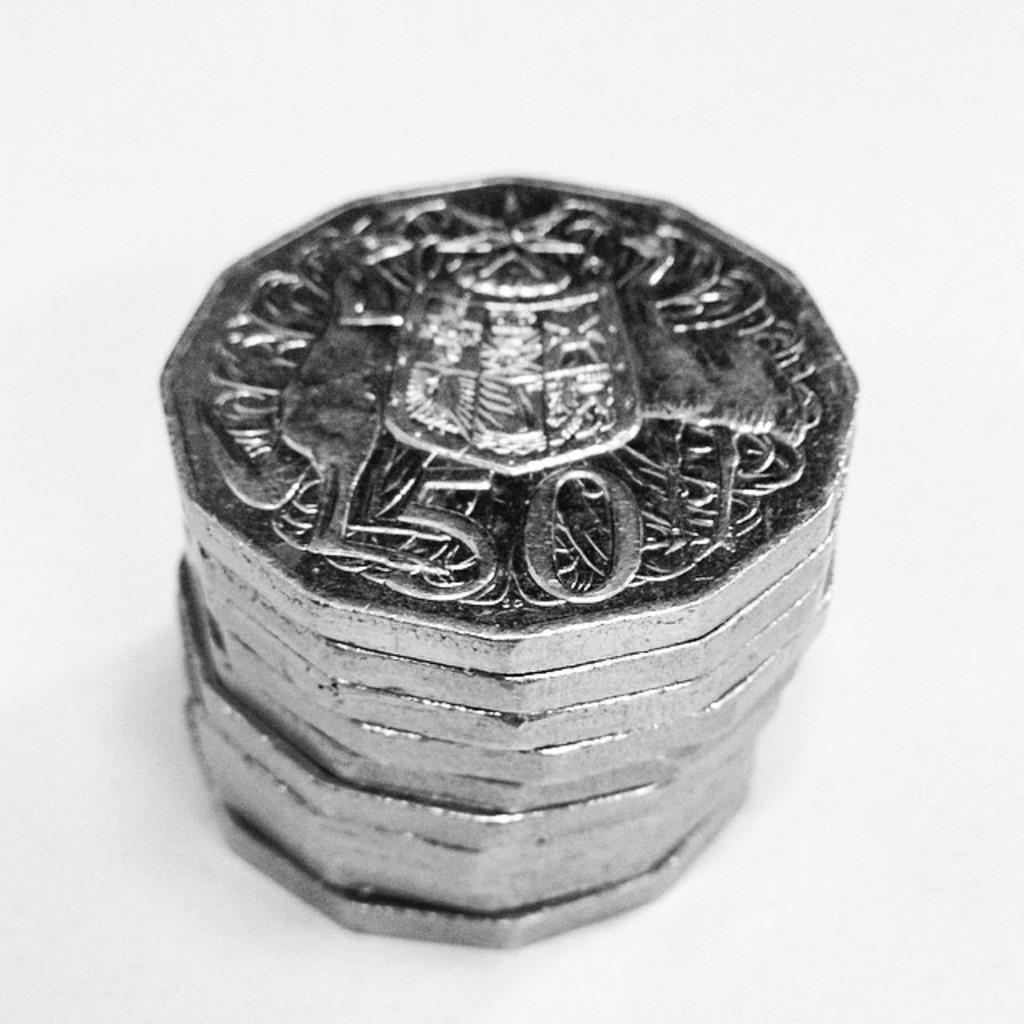Provide a one-sentence caption for the provided image. A stack of silver coins with a denomination of 50. 